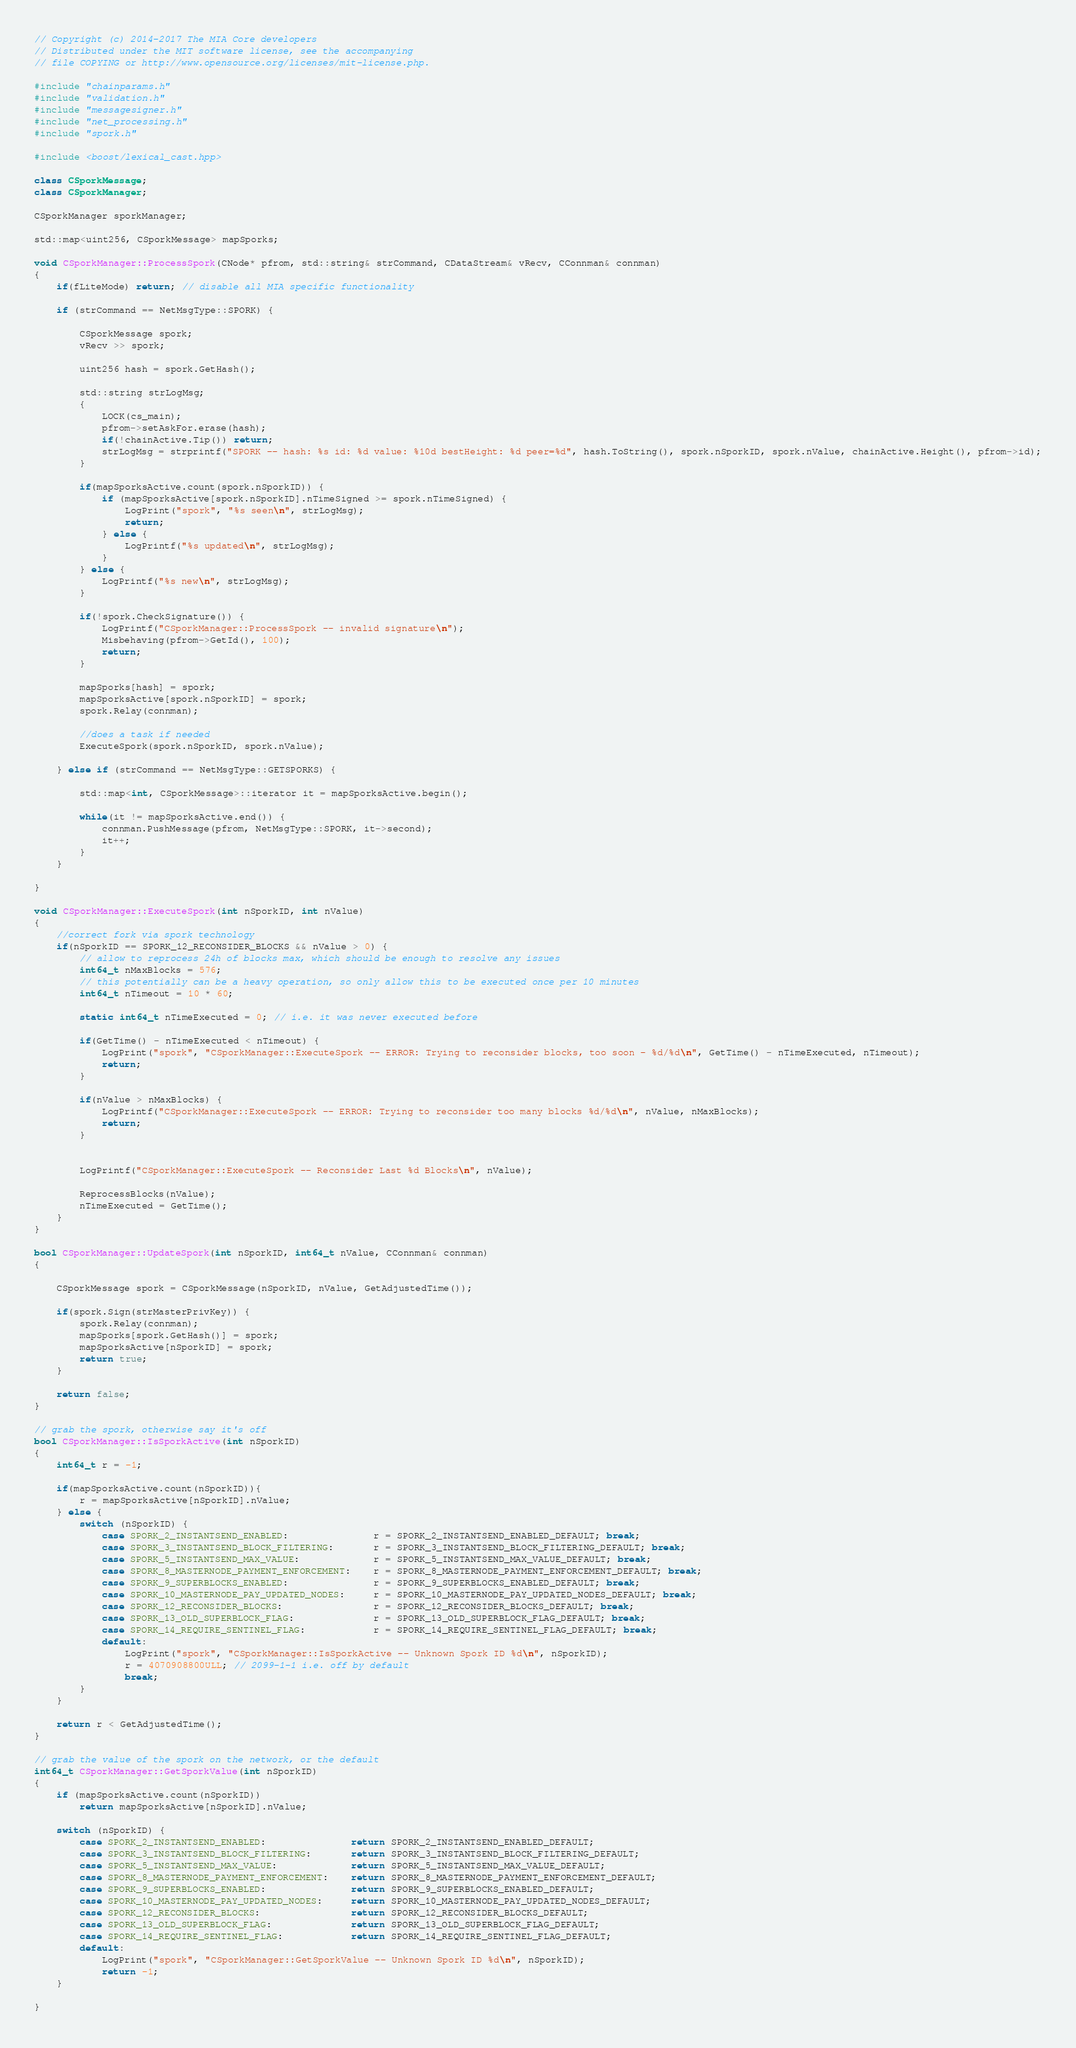Convert code to text. <code><loc_0><loc_0><loc_500><loc_500><_C++_>// Copyright (c) 2014-2017 The MIA Core developers
// Distributed under the MIT software license, see the accompanying
// file COPYING or http://www.opensource.org/licenses/mit-license.php.

#include "chainparams.h"
#include "validation.h"
#include "messagesigner.h"
#include "net_processing.h"
#include "spork.h"

#include <boost/lexical_cast.hpp>

class CSporkMessage;
class CSporkManager;

CSporkManager sporkManager;

std::map<uint256, CSporkMessage> mapSporks;

void CSporkManager::ProcessSpork(CNode* pfrom, std::string& strCommand, CDataStream& vRecv, CConnman& connman)
{
    if(fLiteMode) return; // disable all MIA specific functionality

    if (strCommand == NetMsgType::SPORK) {

        CSporkMessage spork;
        vRecv >> spork;

        uint256 hash = spork.GetHash();

        std::string strLogMsg;
        {
            LOCK(cs_main);
            pfrom->setAskFor.erase(hash);
            if(!chainActive.Tip()) return;
            strLogMsg = strprintf("SPORK -- hash: %s id: %d value: %10d bestHeight: %d peer=%d", hash.ToString(), spork.nSporkID, spork.nValue, chainActive.Height(), pfrom->id);
        }

        if(mapSporksActive.count(spork.nSporkID)) {
            if (mapSporksActive[spork.nSporkID].nTimeSigned >= spork.nTimeSigned) {
                LogPrint("spork", "%s seen\n", strLogMsg);
                return;
            } else {
                LogPrintf("%s updated\n", strLogMsg);
            }
        } else {
            LogPrintf("%s new\n", strLogMsg);
        }

        if(!spork.CheckSignature()) {
            LogPrintf("CSporkManager::ProcessSpork -- invalid signature\n");
            Misbehaving(pfrom->GetId(), 100);
            return;
        }

        mapSporks[hash] = spork;
        mapSporksActive[spork.nSporkID] = spork;
        spork.Relay(connman);

        //does a task if needed
        ExecuteSpork(spork.nSporkID, spork.nValue);

    } else if (strCommand == NetMsgType::GETSPORKS) {

        std::map<int, CSporkMessage>::iterator it = mapSporksActive.begin();

        while(it != mapSporksActive.end()) {
            connman.PushMessage(pfrom, NetMsgType::SPORK, it->second);
            it++;
        }
    }

}

void CSporkManager::ExecuteSpork(int nSporkID, int nValue)
{
    //correct fork via spork technology
    if(nSporkID == SPORK_12_RECONSIDER_BLOCKS && nValue > 0) {
        // allow to reprocess 24h of blocks max, which should be enough to resolve any issues
        int64_t nMaxBlocks = 576;
        // this potentially can be a heavy operation, so only allow this to be executed once per 10 minutes
        int64_t nTimeout = 10 * 60;

        static int64_t nTimeExecuted = 0; // i.e. it was never executed before

        if(GetTime() - nTimeExecuted < nTimeout) {
            LogPrint("spork", "CSporkManager::ExecuteSpork -- ERROR: Trying to reconsider blocks, too soon - %d/%d\n", GetTime() - nTimeExecuted, nTimeout);
            return;
        }

        if(nValue > nMaxBlocks) {
            LogPrintf("CSporkManager::ExecuteSpork -- ERROR: Trying to reconsider too many blocks %d/%d\n", nValue, nMaxBlocks);
            return;
        }


        LogPrintf("CSporkManager::ExecuteSpork -- Reconsider Last %d Blocks\n", nValue);

        ReprocessBlocks(nValue);
        nTimeExecuted = GetTime();
    }
}

bool CSporkManager::UpdateSpork(int nSporkID, int64_t nValue, CConnman& connman)
{

    CSporkMessage spork = CSporkMessage(nSporkID, nValue, GetAdjustedTime());

    if(spork.Sign(strMasterPrivKey)) {
        spork.Relay(connman);
        mapSporks[spork.GetHash()] = spork;
        mapSporksActive[nSporkID] = spork;
        return true;
    }

    return false;
}

// grab the spork, otherwise say it's off
bool CSporkManager::IsSporkActive(int nSporkID)
{
    int64_t r = -1;

    if(mapSporksActive.count(nSporkID)){
        r = mapSporksActive[nSporkID].nValue;
    } else {
        switch (nSporkID) {
            case SPORK_2_INSTANTSEND_ENABLED:               r = SPORK_2_INSTANTSEND_ENABLED_DEFAULT; break;
            case SPORK_3_INSTANTSEND_BLOCK_FILTERING:       r = SPORK_3_INSTANTSEND_BLOCK_FILTERING_DEFAULT; break;
            case SPORK_5_INSTANTSEND_MAX_VALUE:             r = SPORK_5_INSTANTSEND_MAX_VALUE_DEFAULT; break;
            case SPORK_8_MASTERNODE_PAYMENT_ENFORCEMENT:    r = SPORK_8_MASTERNODE_PAYMENT_ENFORCEMENT_DEFAULT; break;
            case SPORK_9_SUPERBLOCKS_ENABLED:               r = SPORK_9_SUPERBLOCKS_ENABLED_DEFAULT; break;
            case SPORK_10_MASTERNODE_PAY_UPDATED_NODES:     r = SPORK_10_MASTERNODE_PAY_UPDATED_NODES_DEFAULT; break;
            case SPORK_12_RECONSIDER_BLOCKS:                r = SPORK_12_RECONSIDER_BLOCKS_DEFAULT; break;
            case SPORK_13_OLD_SUPERBLOCK_FLAG:              r = SPORK_13_OLD_SUPERBLOCK_FLAG_DEFAULT; break;
            case SPORK_14_REQUIRE_SENTINEL_FLAG:            r = SPORK_14_REQUIRE_SENTINEL_FLAG_DEFAULT; break;
            default:
                LogPrint("spork", "CSporkManager::IsSporkActive -- Unknown Spork ID %d\n", nSporkID);
                r = 4070908800ULL; // 2099-1-1 i.e. off by default
                break;
        }
    }

    return r < GetAdjustedTime();
}

// grab the value of the spork on the network, or the default
int64_t CSporkManager::GetSporkValue(int nSporkID)
{
    if (mapSporksActive.count(nSporkID))
        return mapSporksActive[nSporkID].nValue;

    switch (nSporkID) {
        case SPORK_2_INSTANTSEND_ENABLED:               return SPORK_2_INSTANTSEND_ENABLED_DEFAULT;
        case SPORK_3_INSTANTSEND_BLOCK_FILTERING:       return SPORK_3_INSTANTSEND_BLOCK_FILTERING_DEFAULT;
        case SPORK_5_INSTANTSEND_MAX_VALUE:             return SPORK_5_INSTANTSEND_MAX_VALUE_DEFAULT;
        case SPORK_8_MASTERNODE_PAYMENT_ENFORCEMENT:    return SPORK_8_MASTERNODE_PAYMENT_ENFORCEMENT_DEFAULT;
        case SPORK_9_SUPERBLOCKS_ENABLED:               return SPORK_9_SUPERBLOCKS_ENABLED_DEFAULT;
        case SPORK_10_MASTERNODE_PAY_UPDATED_NODES:     return SPORK_10_MASTERNODE_PAY_UPDATED_NODES_DEFAULT;
        case SPORK_12_RECONSIDER_BLOCKS:                return SPORK_12_RECONSIDER_BLOCKS_DEFAULT;
        case SPORK_13_OLD_SUPERBLOCK_FLAG:              return SPORK_13_OLD_SUPERBLOCK_FLAG_DEFAULT;
        case SPORK_14_REQUIRE_SENTINEL_FLAG:            return SPORK_14_REQUIRE_SENTINEL_FLAG_DEFAULT;
        default:
            LogPrint("spork", "CSporkManager::GetSporkValue -- Unknown Spork ID %d\n", nSporkID);
            return -1;
    }

}
</code> 